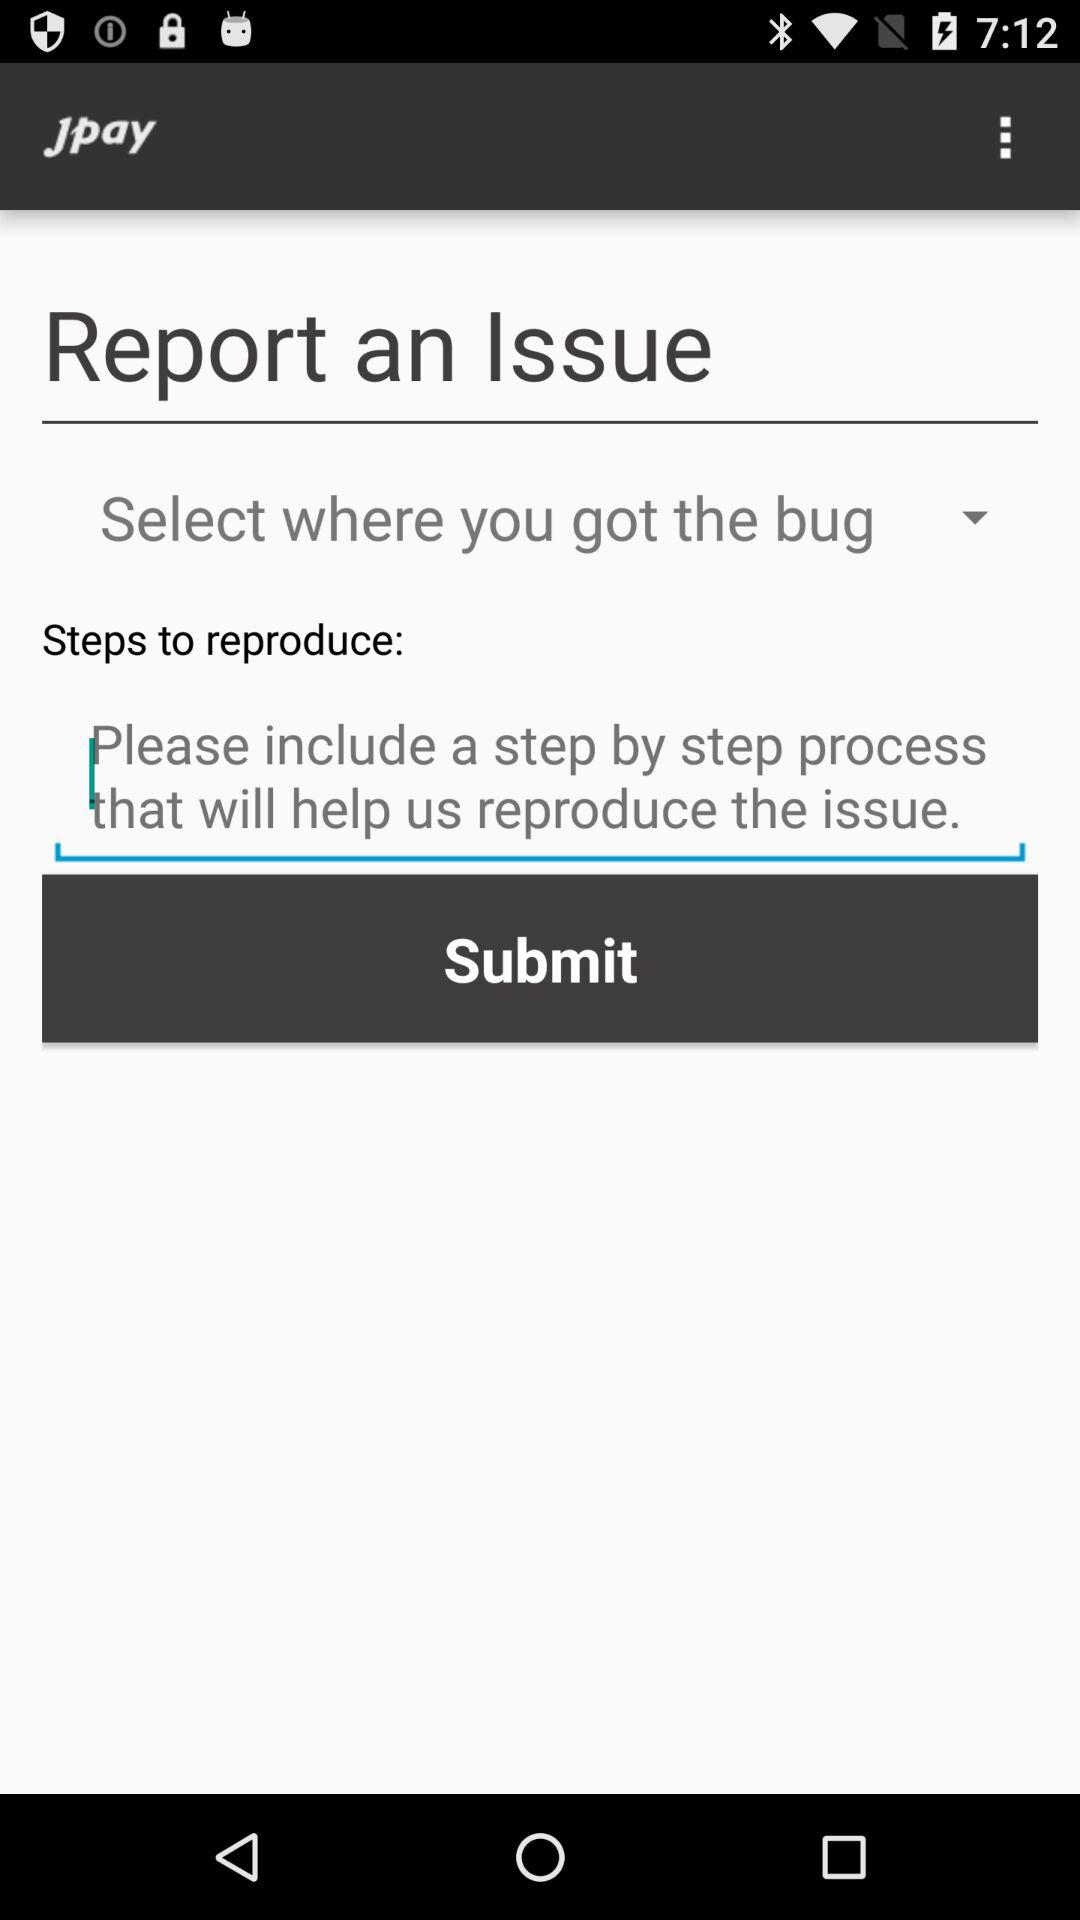What is the name of the application? The name of the application is "jpay". 